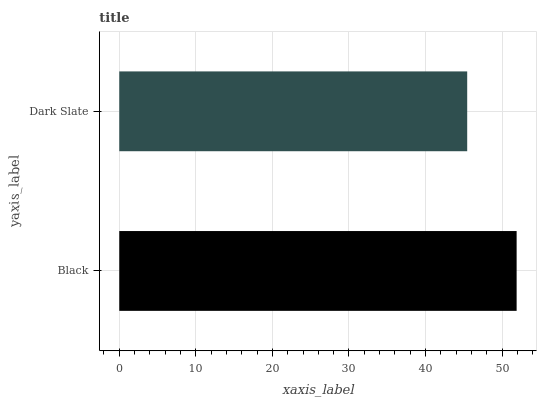Is Dark Slate the minimum?
Answer yes or no. Yes. Is Black the maximum?
Answer yes or no. Yes. Is Dark Slate the maximum?
Answer yes or no. No. Is Black greater than Dark Slate?
Answer yes or no. Yes. Is Dark Slate less than Black?
Answer yes or no. Yes. Is Dark Slate greater than Black?
Answer yes or no. No. Is Black less than Dark Slate?
Answer yes or no. No. Is Black the high median?
Answer yes or no. Yes. Is Dark Slate the low median?
Answer yes or no. Yes. Is Dark Slate the high median?
Answer yes or no. No. Is Black the low median?
Answer yes or no. No. 